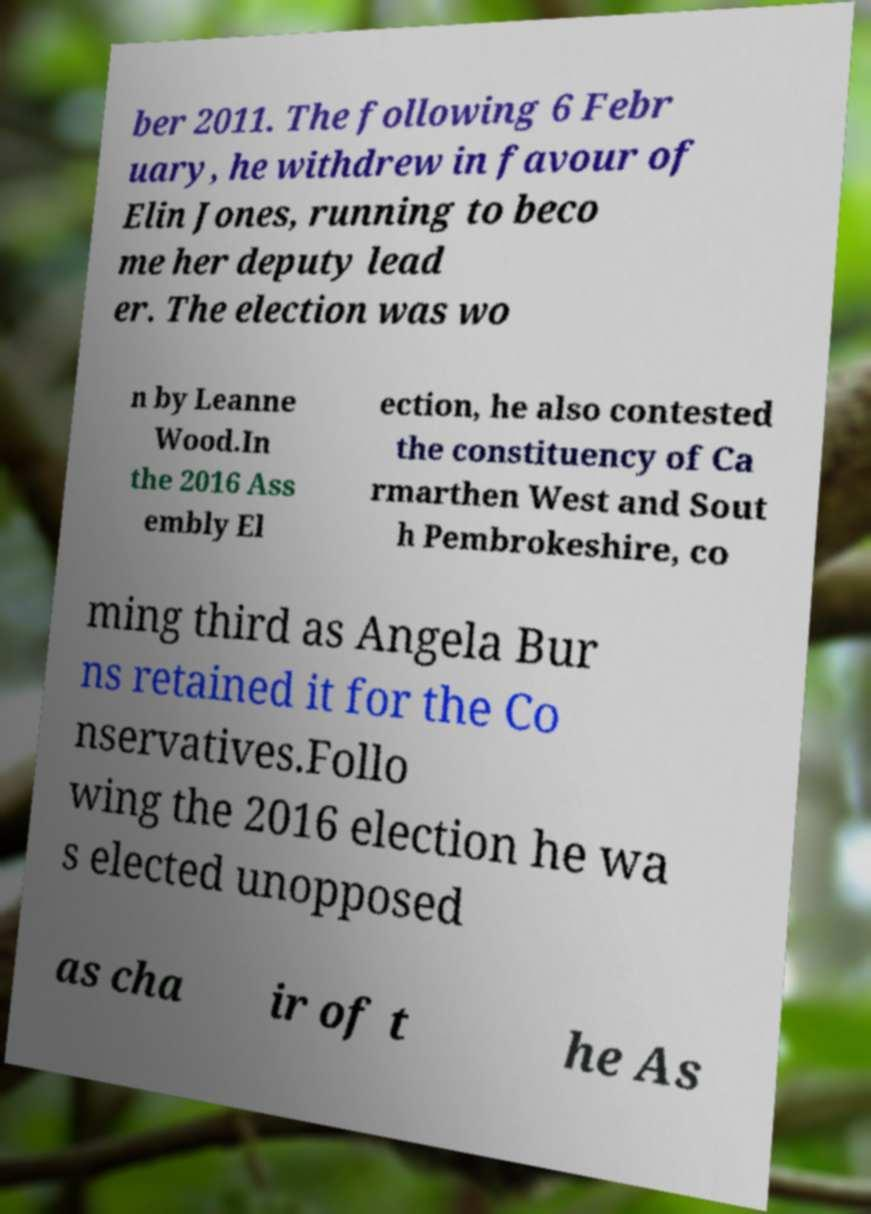For documentation purposes, I need the text within this image transcribed. Could you provide that? ber 2011. The following 6 Febr uary, he withdrew in favour of Elin Jones, running to beco me her deputy lead er. The election was wo n by Leanne Wood.In the 2016 Ass embly El ection, he also contested the constituency of Ca rmarthen West and Sout h Pembrokeshire, co ming third as Angela Bur ns retained it for the Co nservatives.Follo wing the 2016 election he wa s elected unopposed as cha ir of t he As 